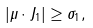<formula> <loc_0><loc_0><loc_500><loc_500>| \mu \cdot J _ { 1 } | \geq \sigma _ { 1 } ,</formula> 